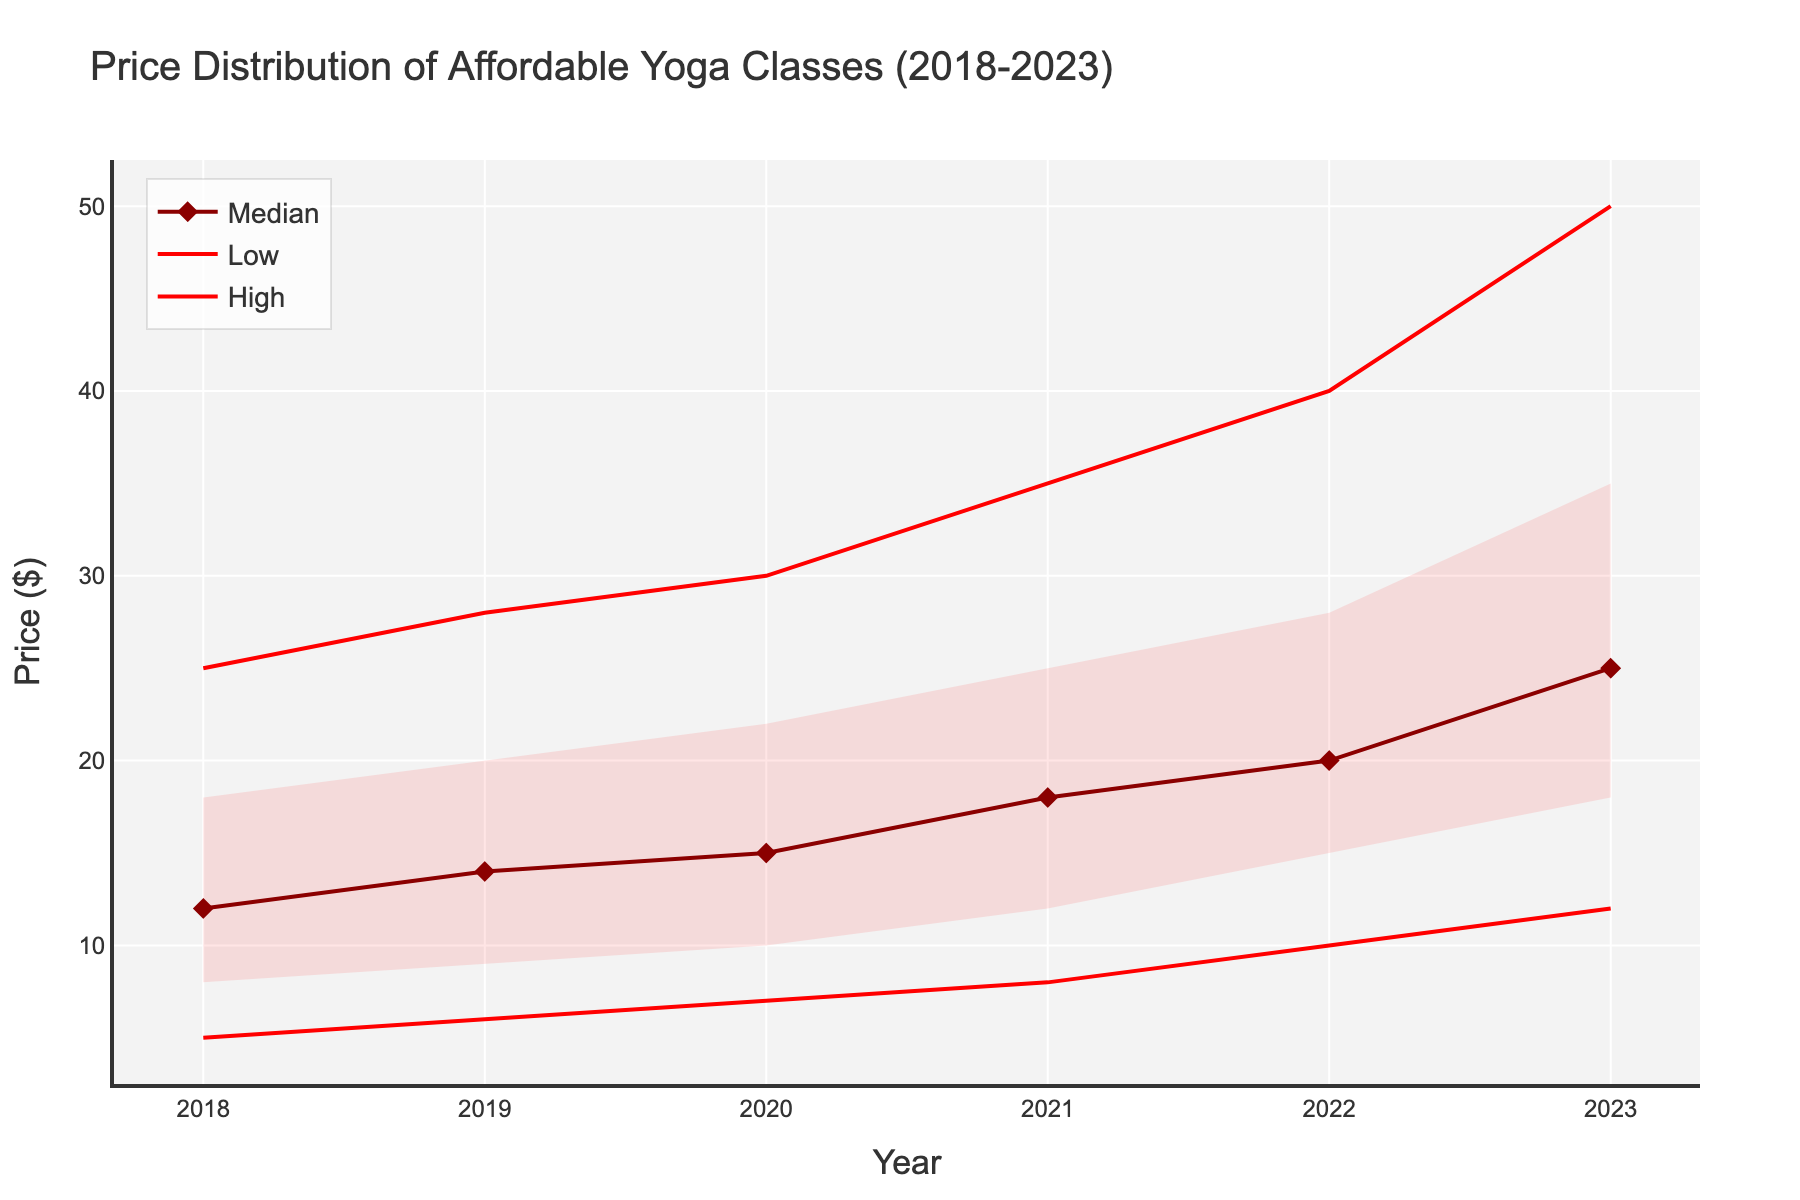What is the title of the figure? The title of the figure is displayed at the top and provides an overview of what the visual represents.
Answer: Price Distribution of Affordable Yoga Classes (2018-2023) What is the y-axis label? The y-axis label is displayed along the vertical axis, indicating what the axis represents.
Answer: Price ($) What is the trend of the median price from 2018 to 2023? To identify the trend, follow the line tracking the median price from 2018 to 2023 and notice whether it generally increases, decreases, or remains constant.
Answer: It increases Which year has the lowest "Low" price? Observing the "Low" price line, identify the year where this line reaches its minimum point.
Answer: 2018 What is the median price in 2020? Find the median line in the chart and look at the corresponding value for the year 2020.
Answer: $15 What is the range of prices in 2021? To determine the range, calculate the difference between the highest and lowest values in 2021 (High - Low).
Answer: $35 - $8 = $27 How does the price range between Q1 and Q3 change from 2018 to 2023? For each year, find the values of Q1 and Q3, then calculate Q3 - Q1 to get the interquartile range, and observe the changes over the years.
Answer: It increases from $10 to $17 Compare the median price in 2019 and 2023. Which year has a higher median price? Look at the median line values for both years and compare them directly.
Answer: 2023 By how much did the median price increase from 2018 to 2023? Subtract the median price in 2018 from the median price in 2023.
Answer: $25 - $12 = $13 What is the interquartile range (IQR) of prices in 2022? Calculate the difference between the Q3 and Q1 values for the year 2022.
Answer: $28 - $15 = $13 